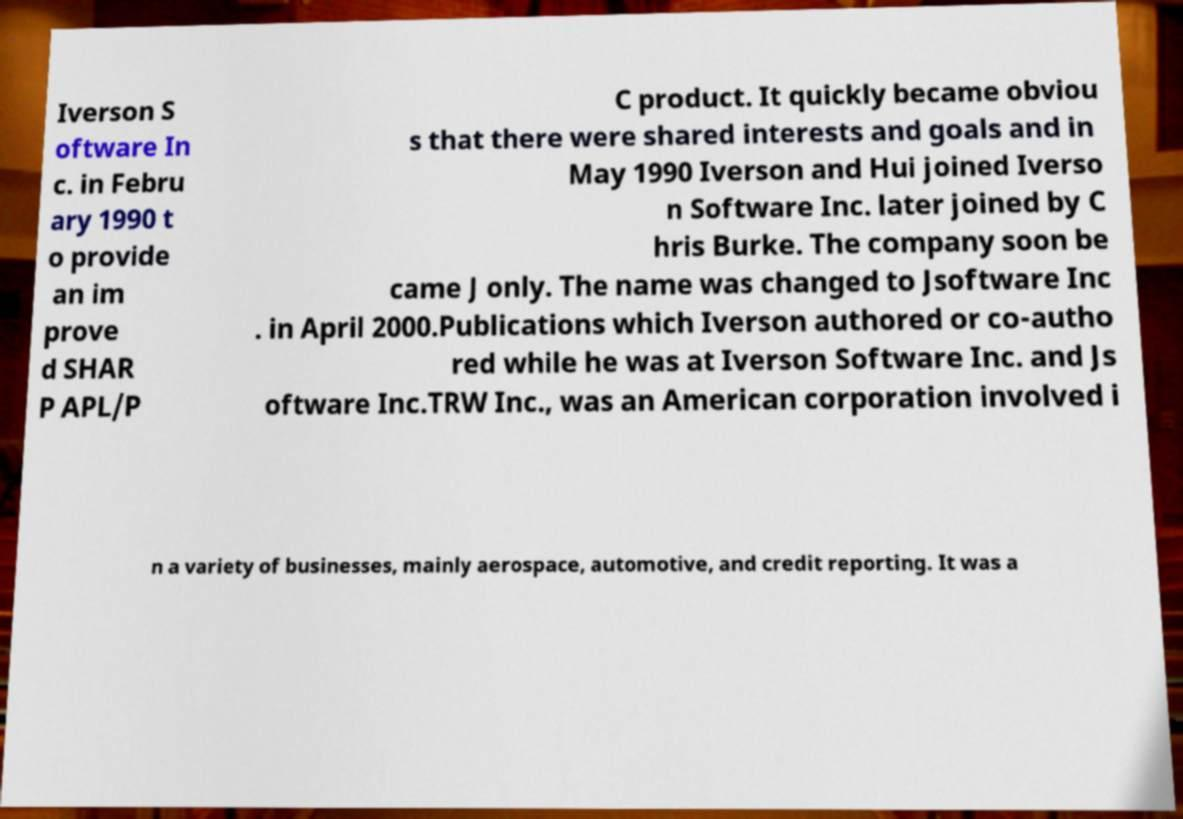Could you extract and type out the text from this image? Iverson S oftware In c. in Febru ary 1990 t o provide an im prove d SHAR P APL/P C product. It quickly became obviou s that there were shared interests and goals and in May 1990 Iverson and Hui joined Iverso n Software Inc. later joined by C hris Burke. The company soon be came J only. The name was changed to Jsoftware Inc . in April 2000.Publications which Iverson authored or co-autho red while he was at Iverson Software Inc. and Js oftware Inc.TRW Inc., was an American corporation involved i n a variety of businesses, mainly aerospace, automotive, and credit reporting. It was a 